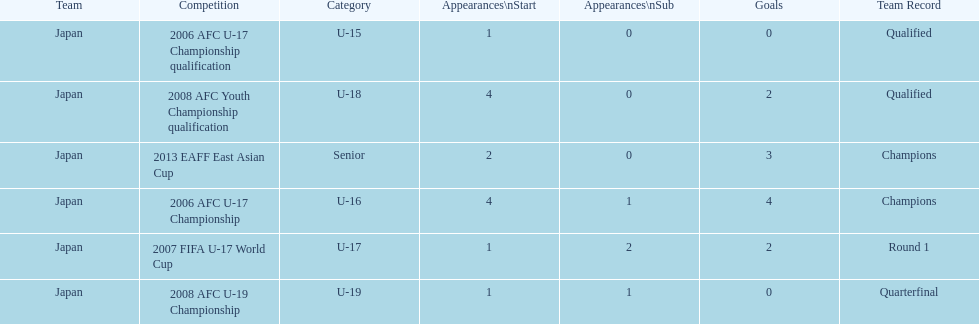Did japan have more starting appearances in the 2013 eaff east asian cup or 2007 fifa u-17 world cup? 2013 EAFF East Asian Cup. 